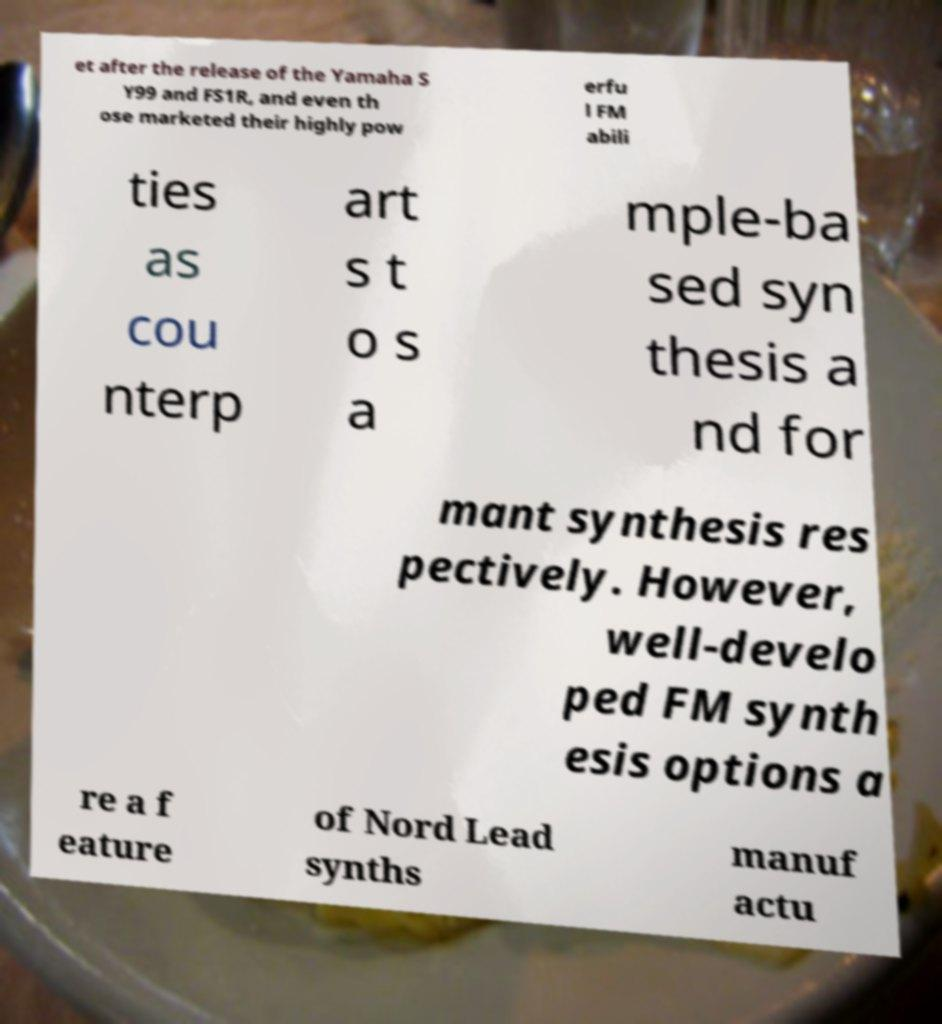There's text embedded in this image that I need extracted. Can you transcribe it verbatim? et after the release of the Yamaha S Y99 and FS1R, and even th ose marketed their highly pow erfu l FM abili ties as cou nterp art s t o s a mple-ba sed syn thesis a nd for mant synthesis res pectively. However, well-develo ped FM synth esis options a re a f eature of Nord Lead synths manuf actu 